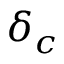<formula> <loc_0><loc_0><loc_500><loc_500>\delta _ { c }</formula> 